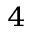Convert formula to latex. <formula><loc_0><loc_0><loc_500><loc_500>^ { 4 }</formula> 